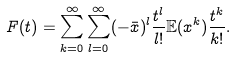Convert formula to latex. <formula><loc_0><loc_0><loc_500><loc_500>F ( t ) = \sum _ { k = 0 } ^ { \infty } \sum _ { l = 0 } ^ { \infty } ( - \bar { x } ) ^ { l } \frac { t ^ { l } } { l ! } \mathbb { E } ( x ^ { k } ) \frac { t ^ { k } } { k ! } .</formula> 